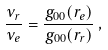<formula> <loc_0><loc_0><loc_500><loc_500>\frac { \nu _ { r } } { \nu _ { e } } = \frac { g _ { 0 0 } ( r _ { e } ) } { g _ { 0 0 } ( r _ { r } ) } \, ,</formula> 